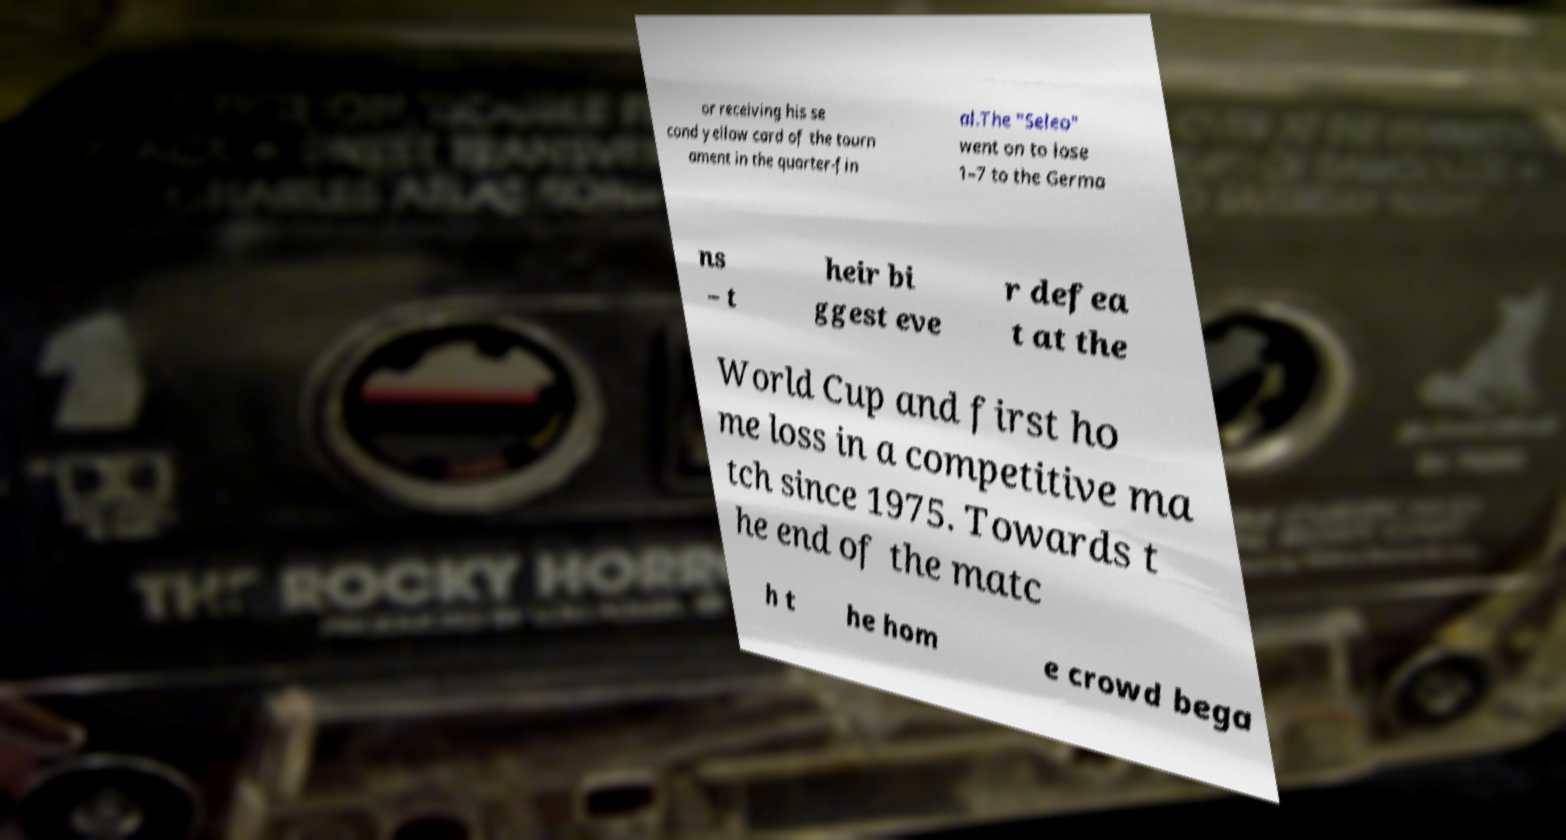Please identify and transcribe the text found in this image. or receiving his se cond yellow card of the tourn ament in the quarter-fin al.The "Seleo" went on to lose 1–7 to the Germa ns – t heir bi ggest eve r defea t at the World Cup and first ho me loss in a competitive ma tch since 1975. Towards t he end of the matc h t he hom e crowd bega 